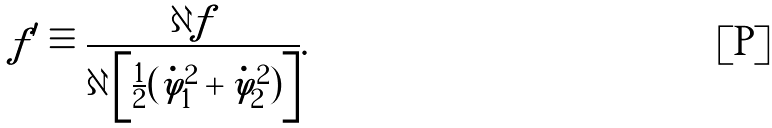Convert formula to latex. <formula><loc_0><loc_0><loc_500><loc_500>f ^ { \prime } \equiv \frac { \partial f } { \partial \left [ \frac { 1 } { 2 } ( \dot { \varphi } _ { 1 } ^ { 2 } + \dot { \varphi } _ { 2 } ^ { 2 } ) \right ] } .</formula> 